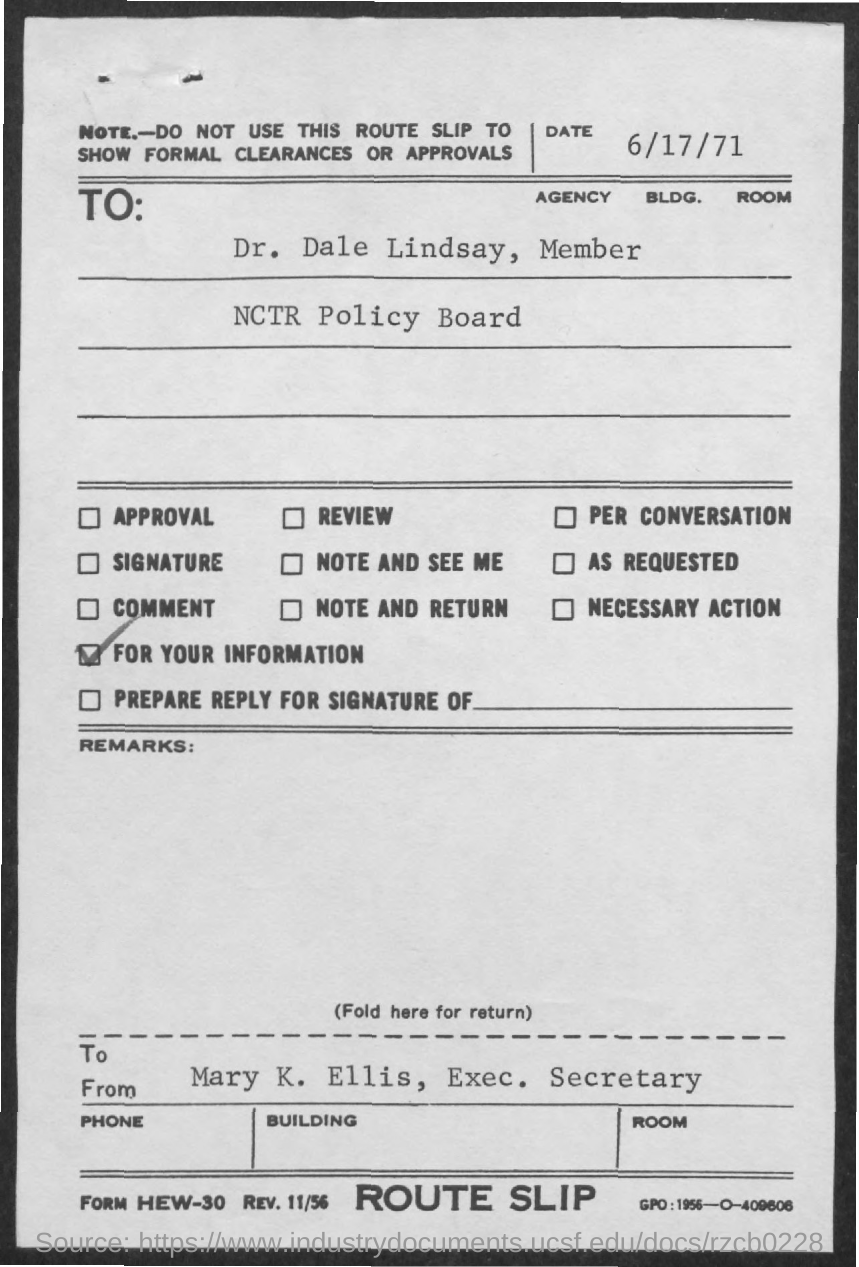What is the date mentioned in the given letter ?
Give a very brief answer. 6/17/71. To whom this letter was written ?
Give a very brief answer. Dr. Dale Lindsay, Member. Dr. Dale Lindsay is the member of which board ?
Provide a short and direct response. NCTR policy board. 